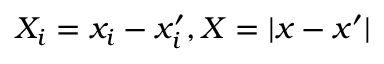<formula> <loc_0><loc_0><loc_500><loc_500>X _ { i } = x _ { i } - x _ { i } ^ { \prime } , X = | x - x ^ { \prime } |</formula> 